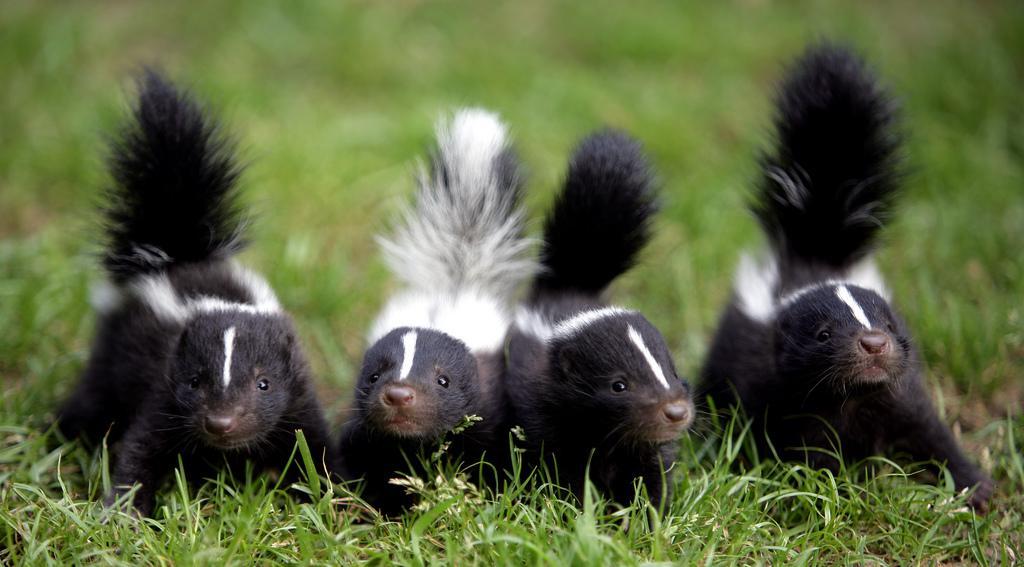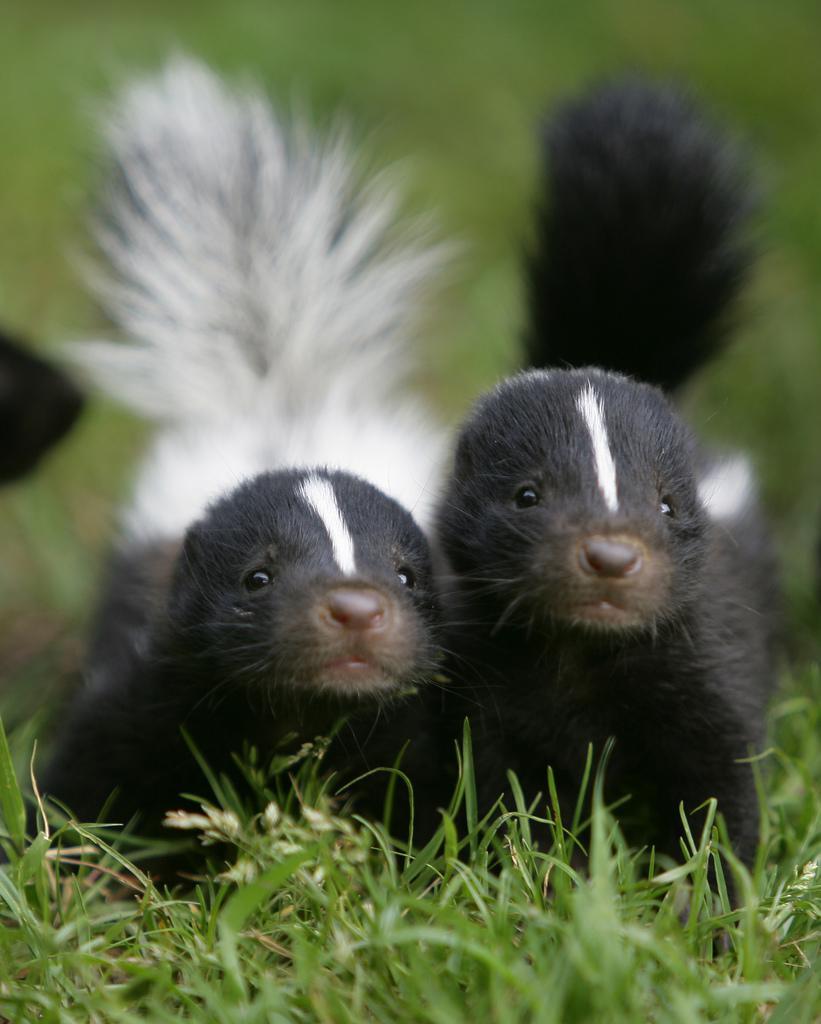The first image is the image on the left, the second image is the image on the right. Examine the images to the left and right. Is the description "In the left image, exactly one raccoon is standing alongside a skunk that is on all fours with its nose pointed down to a brown surface." accurate? Answer yes or no. No. 